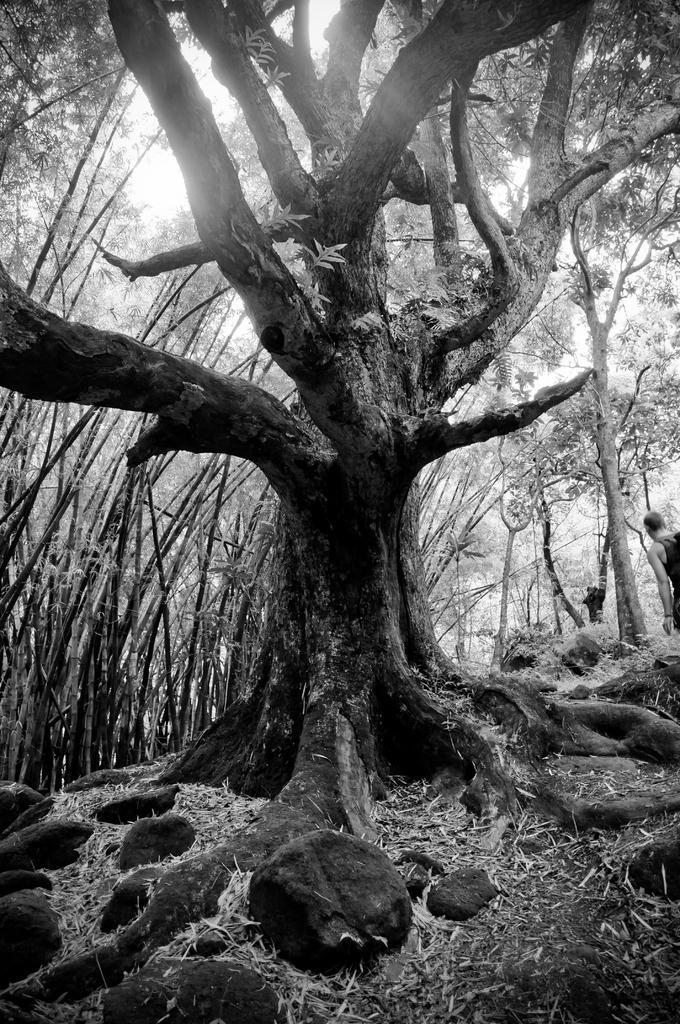Describe this image in one or two sentences. In this image I can see few trees and I can also see the person standing. Background I can see the sky and the image is in black and white. 